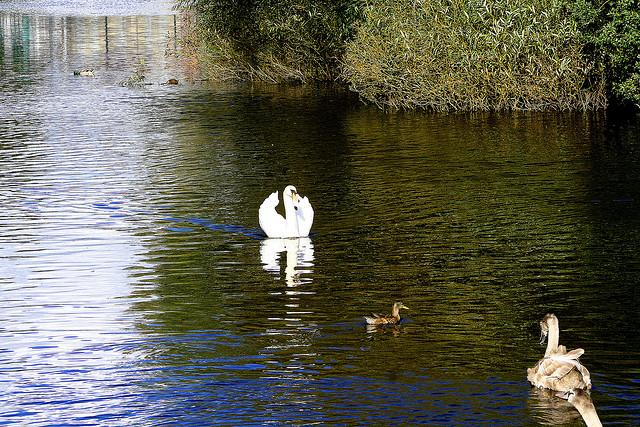What is the smaller bird in between the two larger birds? Please explain your reasoning. duck. There are two swans in between a smaller bird with a small beak. 